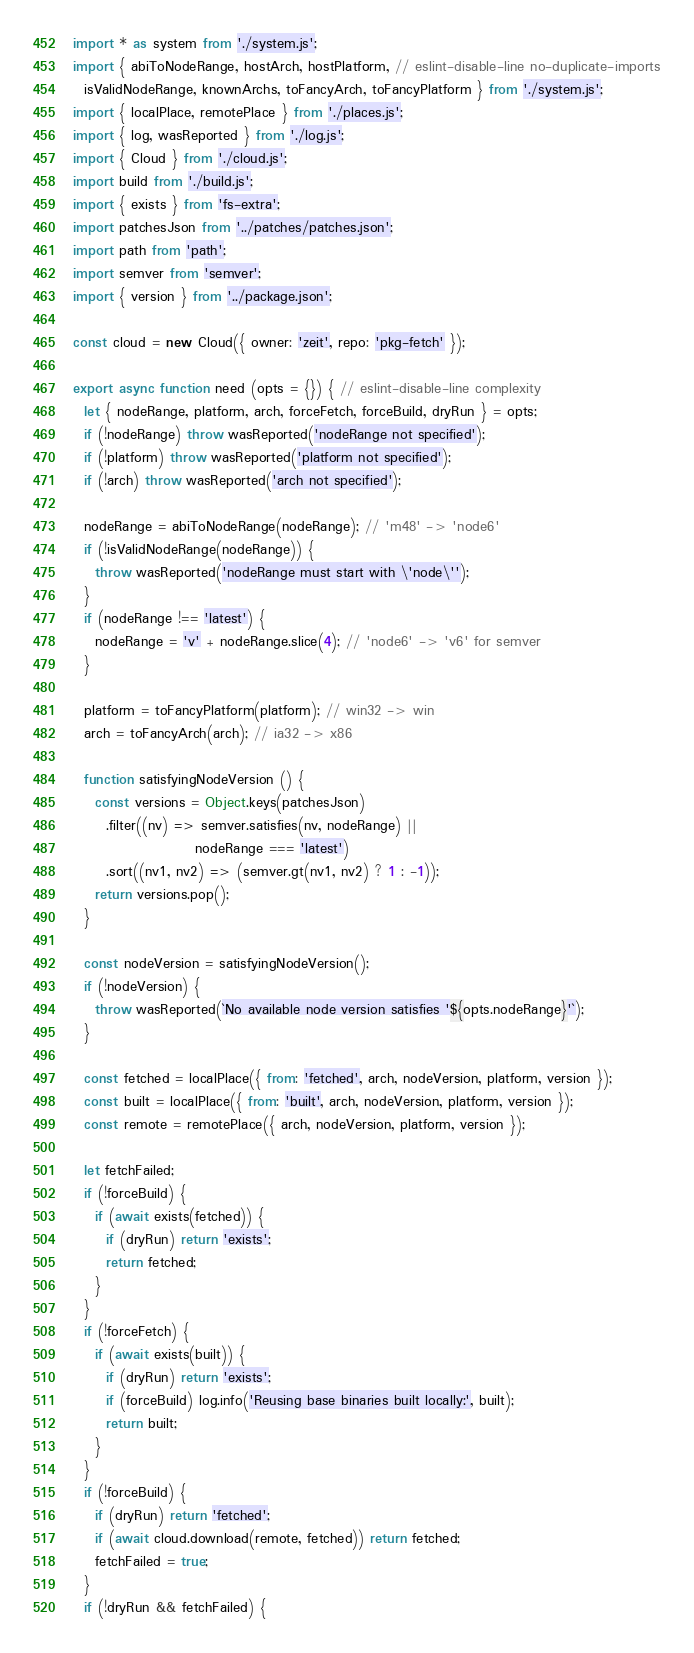Convert code to text. <code><loc_0><loc_0><loc_500><loc_500><_JavaScript_>import * as system from './system.js';
import { abiToNodeRange, hostArch, hostPlatform, // eslint-disable-line no-duplicate-imports
  isValidNodeRange, knownArchs, toFancyArch, toFancyPlatform } from './system.js';
import { localPlace, remotePlace } from './places.js';
import { log, wasReported } from './log.js';
import { Cloud } from './cloud.js';
import build from './build.js';
import { exists } from 'fs-extra';
import patchesJson from '../patches/patches.json';
import path from 'path';
import semver from 'semver';
import { version } from '../package.json';

const cloud = new Cloud({ owner: 'zeit', repo: 'pkg-fetch' });

export async function need (opts = {}) { // eslint-disable-line complexity
  let { nodeRange, platform, arch, forceFetch, forceBuild, dryRun } = opts;
  if (!nodeRange) throw wasReported('nodeRange not specified');
  if (!platform) throw wasReported('platform not specified');
  if (!arch) throw wasReported('arch not specified');

  nodeRange = abiToNodeRange(nodeRange); // 'm48' -> 'node6'
  if (!isValidNodeRange(nodeRange)) {
    throw wasReported('nodeRange must start with \'node\'');
  }
  if (nodeRange !== 'latest') {
    nodeRange = 'v' + nodeRange.slice(4); // 'node6' -> 'v6' for semver
  }

  platform = toFancyPlatform(platform); // win32 -> win
  arch = toFancyArch(arch); // ia32 -> x86

  function satisfyingNodeVersion () {
    const versions = Object.keys(patchesJson)
      .filter((nv) => semver.satisfies(nv, nodeRange) ||
                      nodeRange === 'latest')
      .sort((nv1, nv2) => (semver.gt(nv1, nv2) ? 1 : -1));
    return versions.pop();
  }

  const nodeVersion = satisfyingNodeVersion();
  if (!nodeVersion) {
    throw wasReported(`No available node version satisfies '${opts.nodeRange}'`);
  }

  const fetched = localPlace({ from: 'fetched', arch, nodeVersion, platform, version });
  const built = localPlace({ from: 'built', arch, nodeVersion, platform, version });
  const remote = remotePlace({ arch, nodeVersion, platform, version });

  let fetchFailed;
  if (!forceBuild) {
    if (await exists(fetched)) {
      if (dryRun) return 'exists';
      return fetched;
    }
  }
  if (!forceFetch) {
    if (await exists(built)) {
      if (dryRun) return 'exists';
      if (forceBuild) log.info('Reusing base binaries built locally:', built);
      return built;
    }
  }
  if (!forceBuild) {
    if (dryRun) return 'fetched';
    if (await cloud.download(remote, fetched)) return fetched;
    fetchFailed = true;
  }
  if (!dryRun && fetchFailed) {</code> 